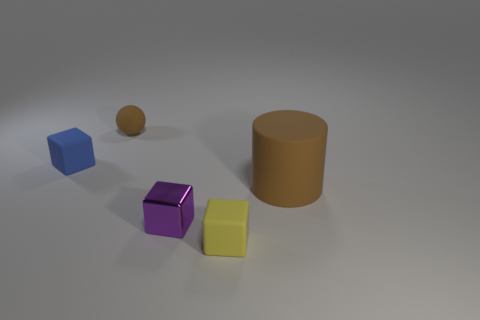Are there more tiny purple shiny objects that are behind the matte cylinder than blocks?
Your response must be concise. No. How many other things are there of the same material as the tiny brown ball?
Your response must be concise. 3. How many small objects are either red blocks or rubber things?
Keep it short and to the point. 3. Is the material of the large thing the same as the tiny brown object?
Offer a very short reply. Yes. What number of tiny metallic objects are on the left side of the tiny matte object that is right of the purple object?
Keep it short and to the point. 1. Is there another yellow matte thing that has the same shape as the big matte thing?
Offer a very short reply. No. Is the shape of the brown matte thing that is to the left of the cylinder the same as the matte thing that is in front of the brown cylinder?
Offer a very short reply. No. The rubber thing that is left of the brown cylinder and in front of the blue rubber object has what shape?
Your answer should be very brief. Cube. Are there any green rubber cubes that have the same size as the ball?
Your answer should be very brief. No. Does the rubber sphere have the same color as the cylinder behind the tiny purple shiny thing?
Ensure brevity in your answer.  Yes. 